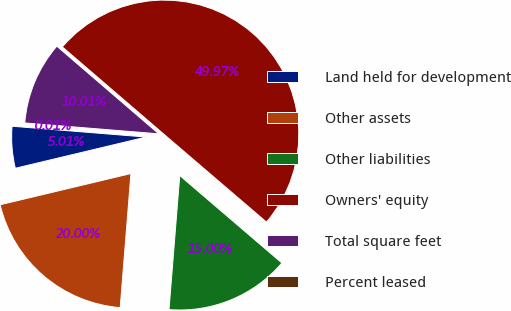Convert chart. <chart><loc_0><loc_0><loc_500><loc_500><pie_chart><fcel>Land held for development<fcel>Other assets<fcel>Other liabilities<fcel>Owners' equity<fcel>Total square feet<fcel>Percent leased<nl><fcel>5.01%<fcel>20.0%<fcel>15.0%<fcel>49.97%<fcel>10.01%<fcel>0.01%<nl></chart> 